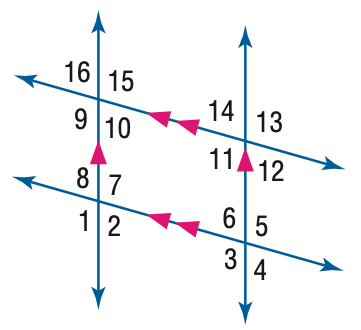Answer the mathemtical geometry problem and directly provide the correct option letter.
Question: In the figure, m \angle 1 = 123. Find the measure of \angle 6.
Choices: A: 47 B: 57 C: 67 D: 123 B 